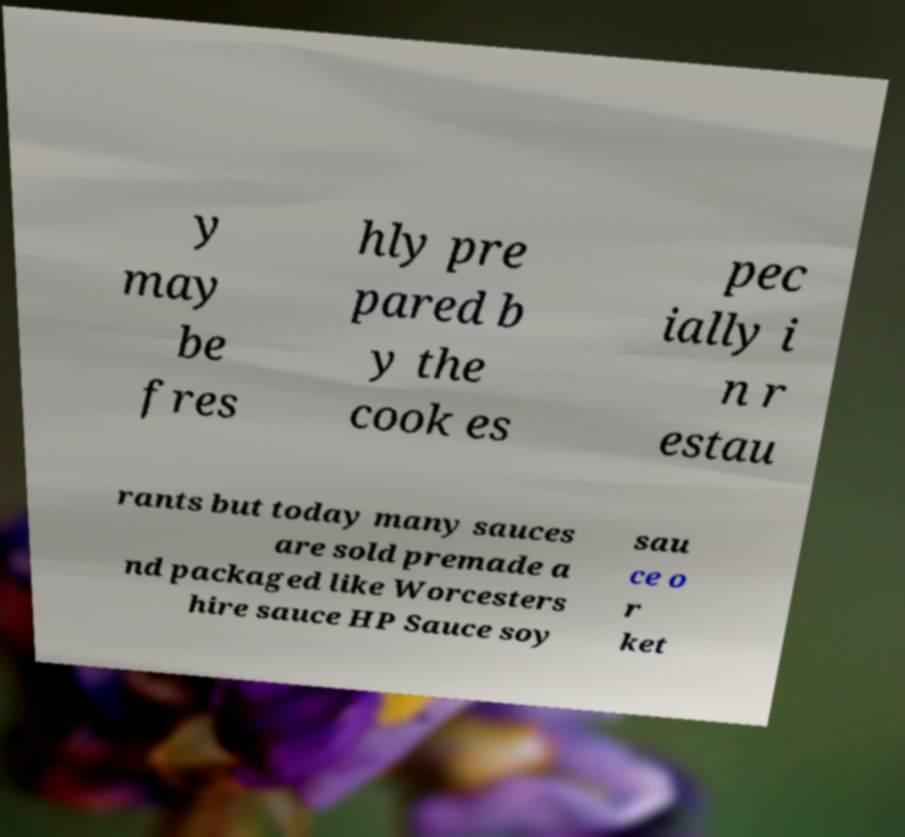I need the written content from this picture converted into text. Can you do that? y may be fres hly pre pared b y the cook es pec ially i n r estau rants but today many sauces are sold premade a nd packaged like Worcesters hire sauce HP Sauce soy sau ce o r ket 